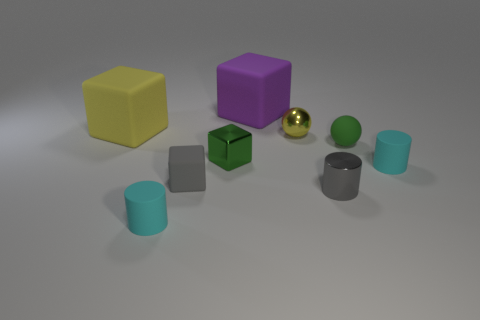How would you describe the lighting in this scene? The lighting in the scene is soft and diffused, casting gentle shadows and highlighting the matte textures of the objects, which suggests an indoor setting possibly with controlled lighting to avoid harsh reflections. 